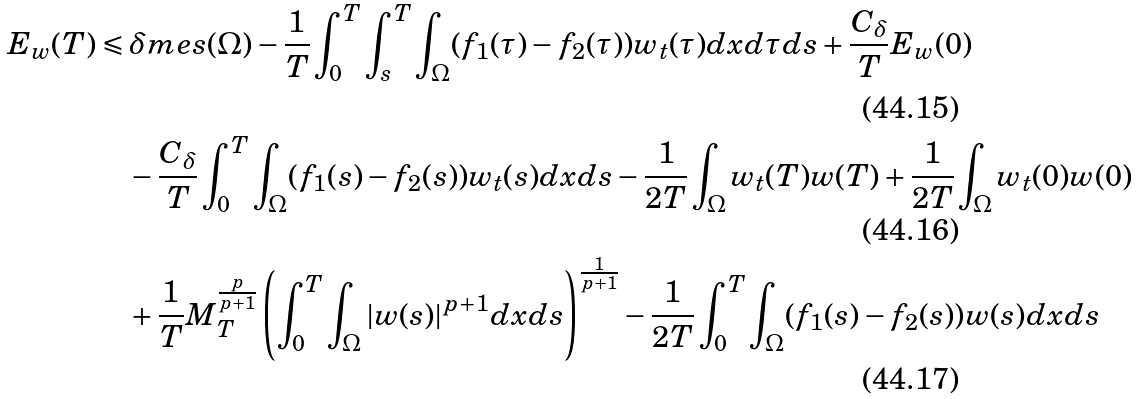<formula> <loc_0><loc_0><loc_500><loc_500>E _ { w } ( T ) & \leqslant \delta m e s ( \Omega ) - \frac { 1 } { T } \int _ { 0 } ^ { T } \int _ { s } ^ { T } \int _ { \Omega } ( f _ { 1 } ( \tau ) - f _ { 2 } ( \tau ) ) w _ { t } ( \tau ) d x d \tau d s + \frac { C _ { \delta } } { T } E _ { w } ( 0 ) \\ & \quad - \frac { C _ { \delta } } { T } \int _ { 0 } ^ { T } \int _ { \Omega } ( f _ { 1 } ( s ) - f _ { 2 } ( s ) ) w _ { t } ( s ) d x d s - \frac { 1 } { 2 T } \int _ { \Omega } w _ { t } ( T ) w ( T ) + \frac { 1 } { 2 T } \int _ { \Omega } w _ { t } ( 0 ) w ( 0 ) \\ & \quad + \frac { 1 } { T } M _ { T } ^ { \frac { p } { p + 1 } } \left ( \int _ { 0 } ^ { T } \int _ { \Omega } | w ( s ) | ^ { p + 1 } d x d s \right ) ^ { \frac { 1 } { p + 1 } } - \frac { 1 } { 2 T } \int _ { 0 } ^ { T } \int _ { \Omega } ( f _ { 1 } ( s ) - f _ { 2 } ( s ) ) w ( s ) d x d s</formula> 